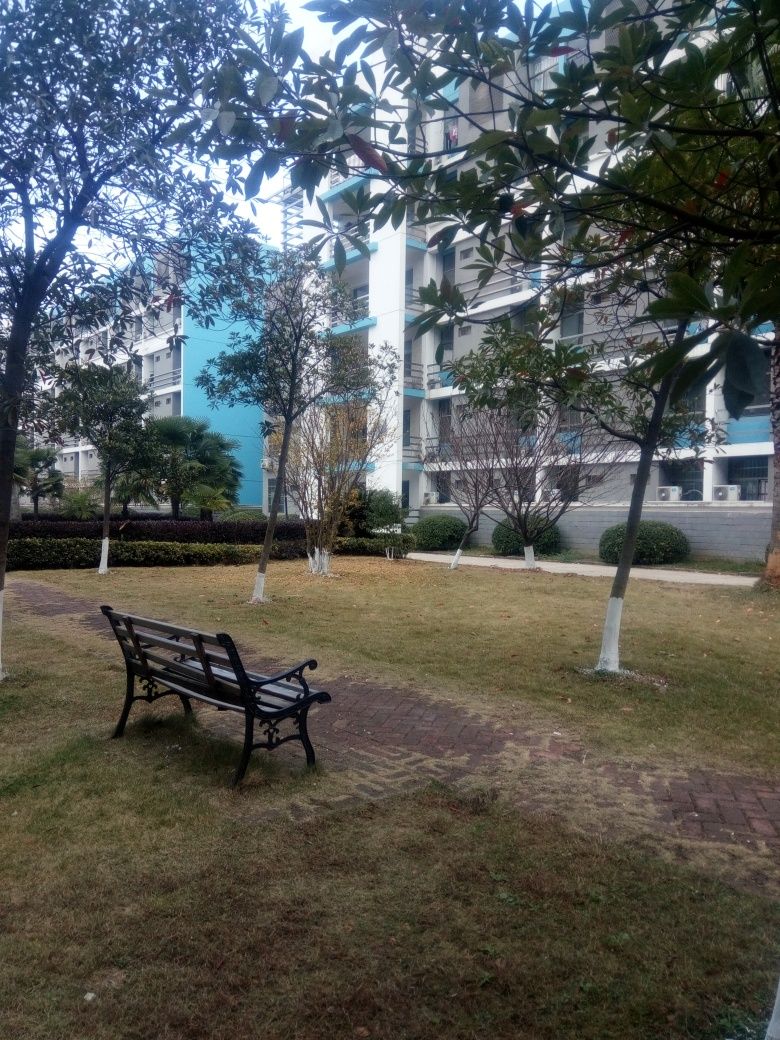What type of location or setting is shown in the image? This image portrays a quiet, landscaped outdoor area, possibly within a residential or campus-like setting. The orderly arrangement of trees and the well-maintained grass alongside a brick pathway suggest a space designed for relaxation and casual pedestrian traffic. The multi-story buildings in the background with symmetric balconies reinforce the idea of a residential community. 